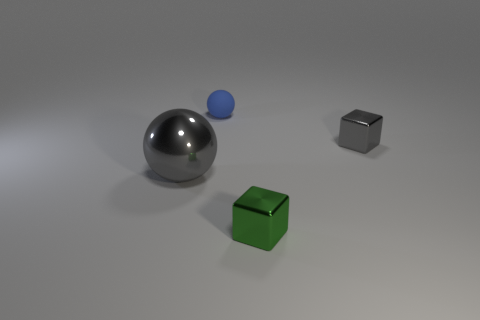Subtract all gray balls. How many balls are left? 1 Subtract 1 spheres. How many spheres are left? 1 Subtract all red balls. Subtract all green cubes. How many balls are left? 2 Subtract all gray cubes. How many brown spheres are left? 0 Subtract all tiny blocks. Subtract all purple spheres. How many objects are left? 2 Add 4 small metal blocks. How many small metal blocks are left? 6 Add 3 small green shiny things. How many small green shiny things exist? 4 Add 3 small red matte blocks. How many objects exist? 7 Subtract 0 red spheres. How many objects are left? 4 